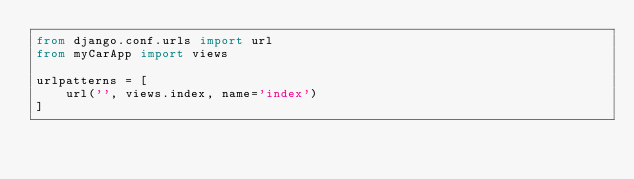<code> <loc_0><loc_0><loc_500><loc_500><_Python_>from django.conf.urls import url
from myCarApp import views

urlpatterns = [
    url('', views.index, name='index')
]
</code> 